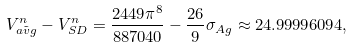Convert formula to latex. <formula><loc_0><loc_0><loc_500><loc_500>V ^ { n } _ { \tilde { a v g } } - V ^ { n } _ { S D } = \frac { 2 4 4 9 \pi ^ { 8 } } { 8 8 7 0 4 0 } - \frac { 2 6 } { 9 } \sigma _ { A g } \approx 2 4 . 9 9 9 9 6 0 9 4 ,</formula> 